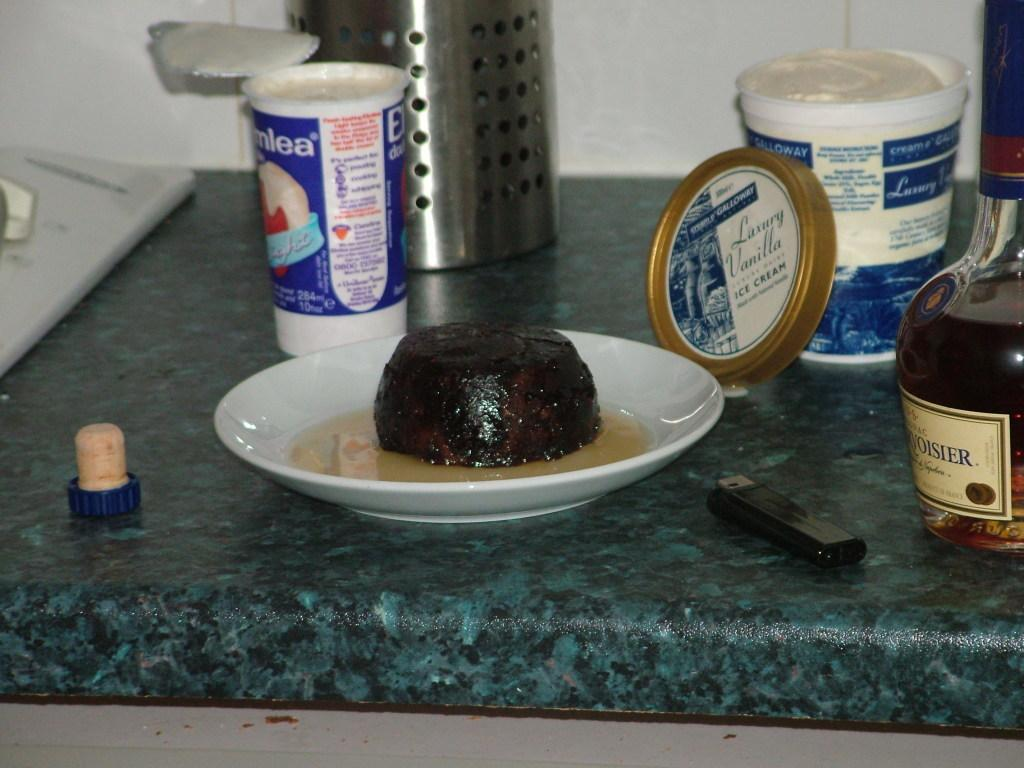<image>
Write a terse but informative summary of the picture. A jar of ice cream is behind a mound of brown stuff on a  plate. 